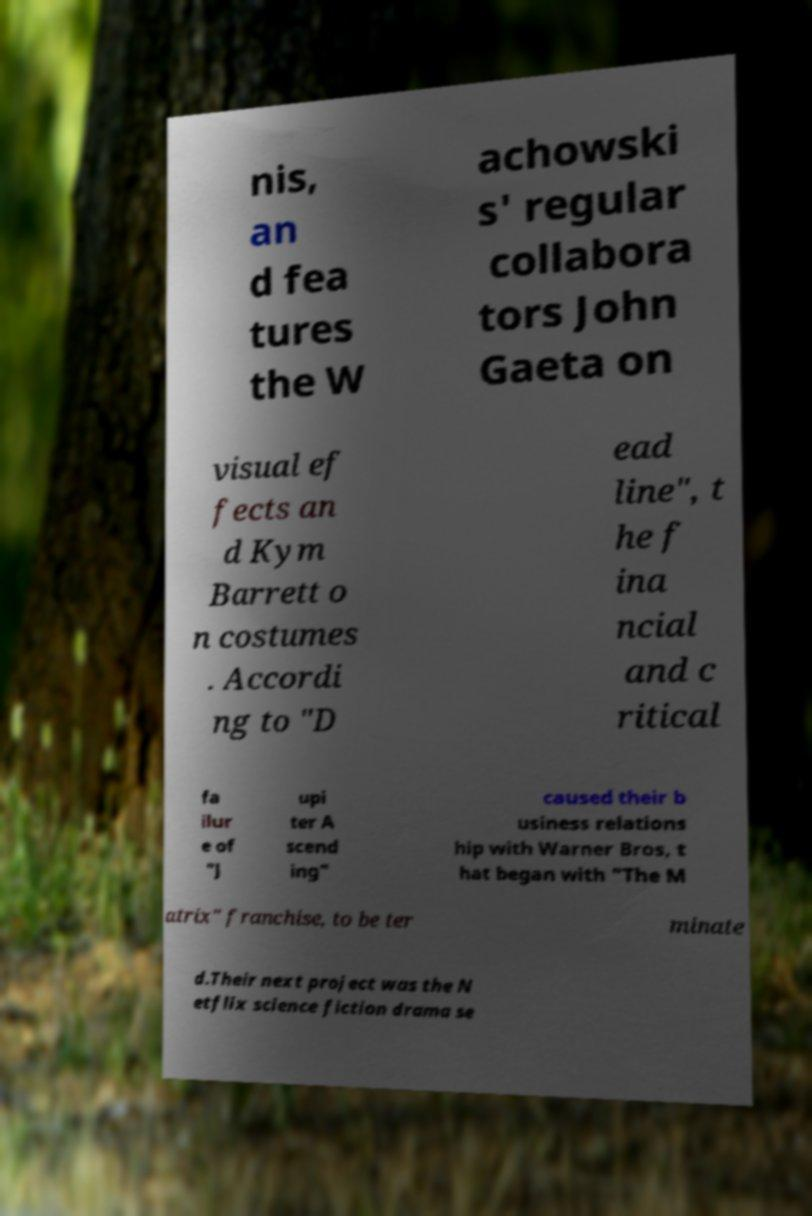There's text embedded in this image that I need extracted. Can you transcribe it verbatim? nis, an d fea tures the W achowski s' regular collabora tors John Gaeta on visual ef fects an d Kym Barrett o n costumes . Accordi ng to "D ead line", t he f ina ncial and c ritical fa ilur e of "J upi ter A scend ing" caused their b usiness relations hip with Warner Bros, t hat began with "The M atrix" franchise, to be ter minate d.Their next project was the N etflix science fiction drama se 